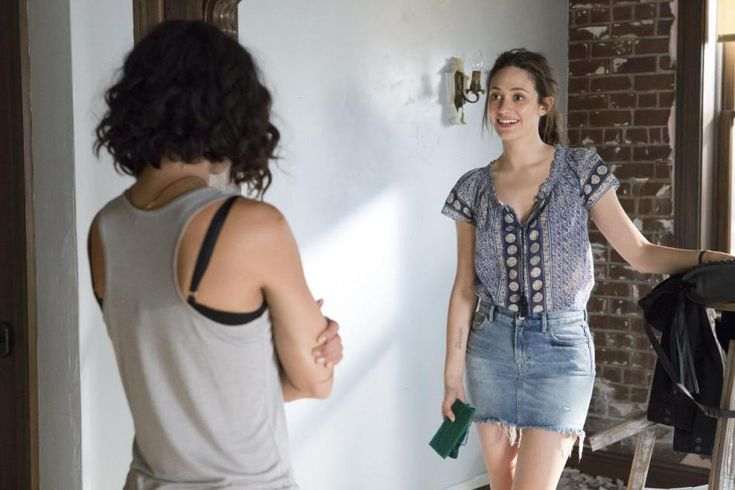What are the key elements in this picture? In this photograph, two women are engaged in a conversation. The woman on the right is standing in a room with a rustic brick wall and holding a black bag in her right arm and a green object (possibly a book or notebook) in her left hand. She is dressed in a casual yet stylish outfit consisting of a blue denim skirt and a patterned blouse with gray and white shades. The woman on the left, whose back is to the camera, is wearing a gray tank top with a black bra strap visible. The room's minimalist decor includes a wall sconce and a wooden ladder leaning against the wall, contributing to the cozy atmosphere. The interaction seems warm and friendly, with the woman on the right smiling warmly. 